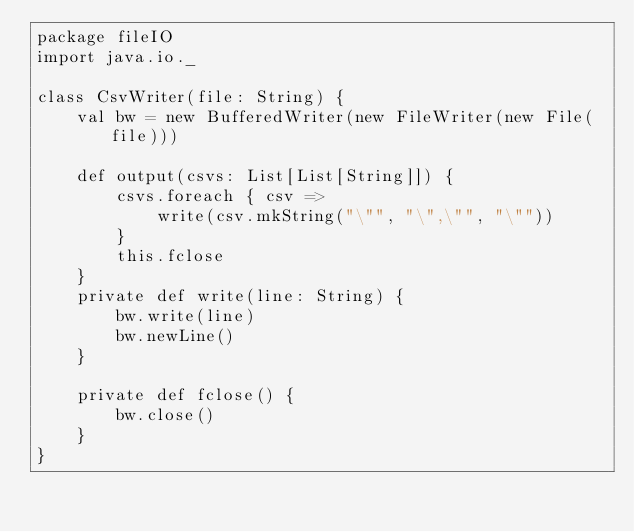<code> <loc_0><loc_0><loc_500><loc_500><_Scala_>package fileIO
import java.io._

class CsvWriter(file: String) {
	val bw = new BufferedWriter(new FileWriter(new File(file)))

	def output(csvs: List[List[String]]) {
		csvs.foreach { csv =>
			write(csv.mkString("\"", "\",\"", "\""))
		}
		this.fclose
	}
	private def write(line: String) {
		bw.write(line)
		bw.newLine()
	}

	private def fclose() {
		bw.close()
	}
}</code> 